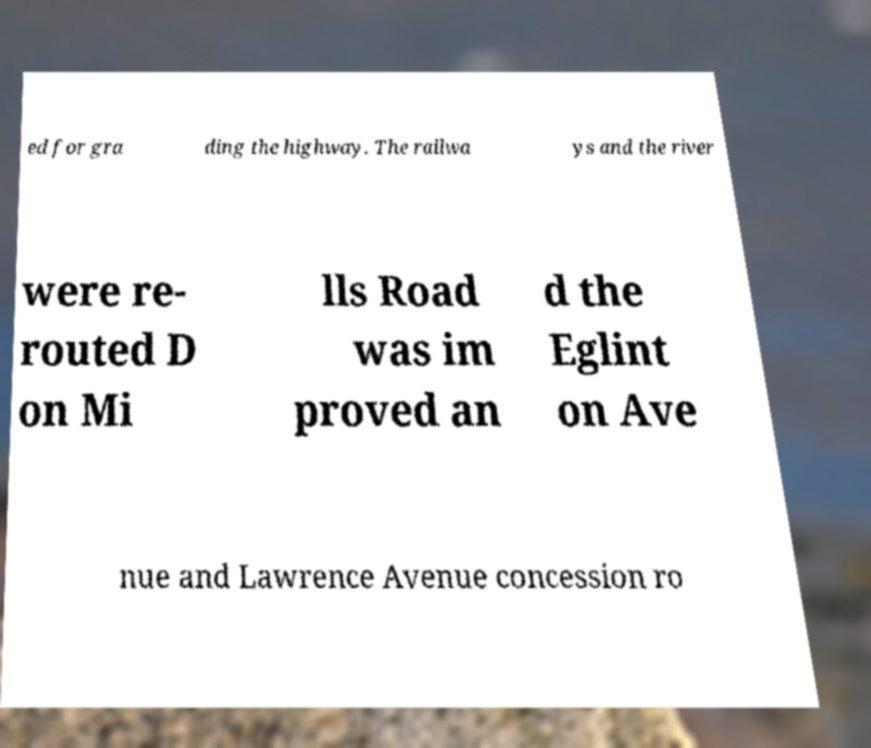I need the written content from this picture converted into text. Can you do that? ed for gra ding the highway. The railwa ys and the river were re- routed D on Mi lls Road was im proved an d the Eglint on Ave nue and Lawrence Avenue concession ro 